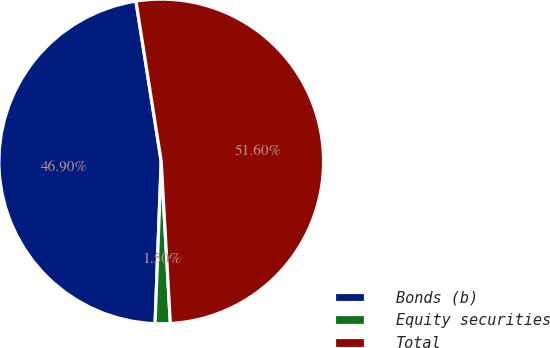Convert chart to OTSL. <chart><loc_0><loc_0><loc_500><loc_500><pie_chart><fcel>Bonds (b)<fcel>Equity securities<fcel>Total<nl><fcel>46.9%<fcel>1.5%<fcel>51.59%<nl></chart> 